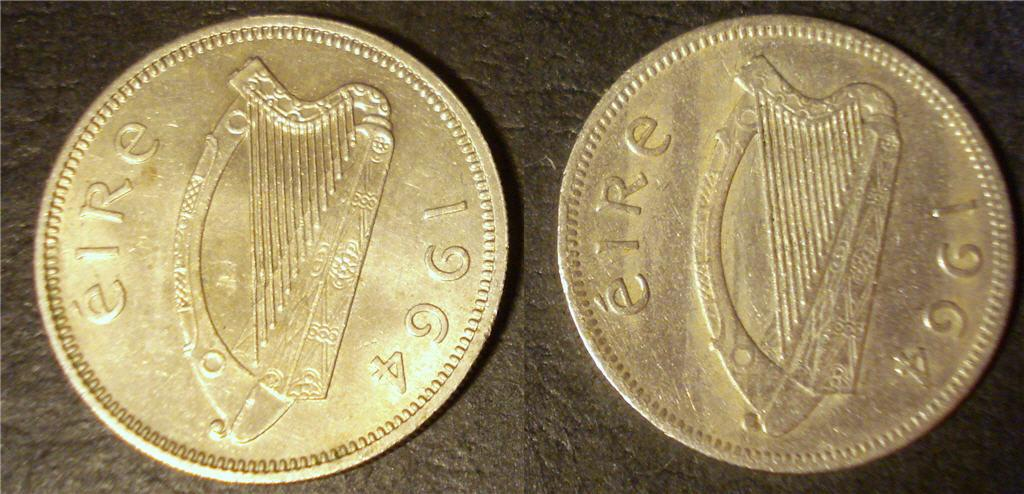<image>
Relay a brief, clear account of the picture shown. Two Irish coins from 1964 - with the word Eire stamped. 